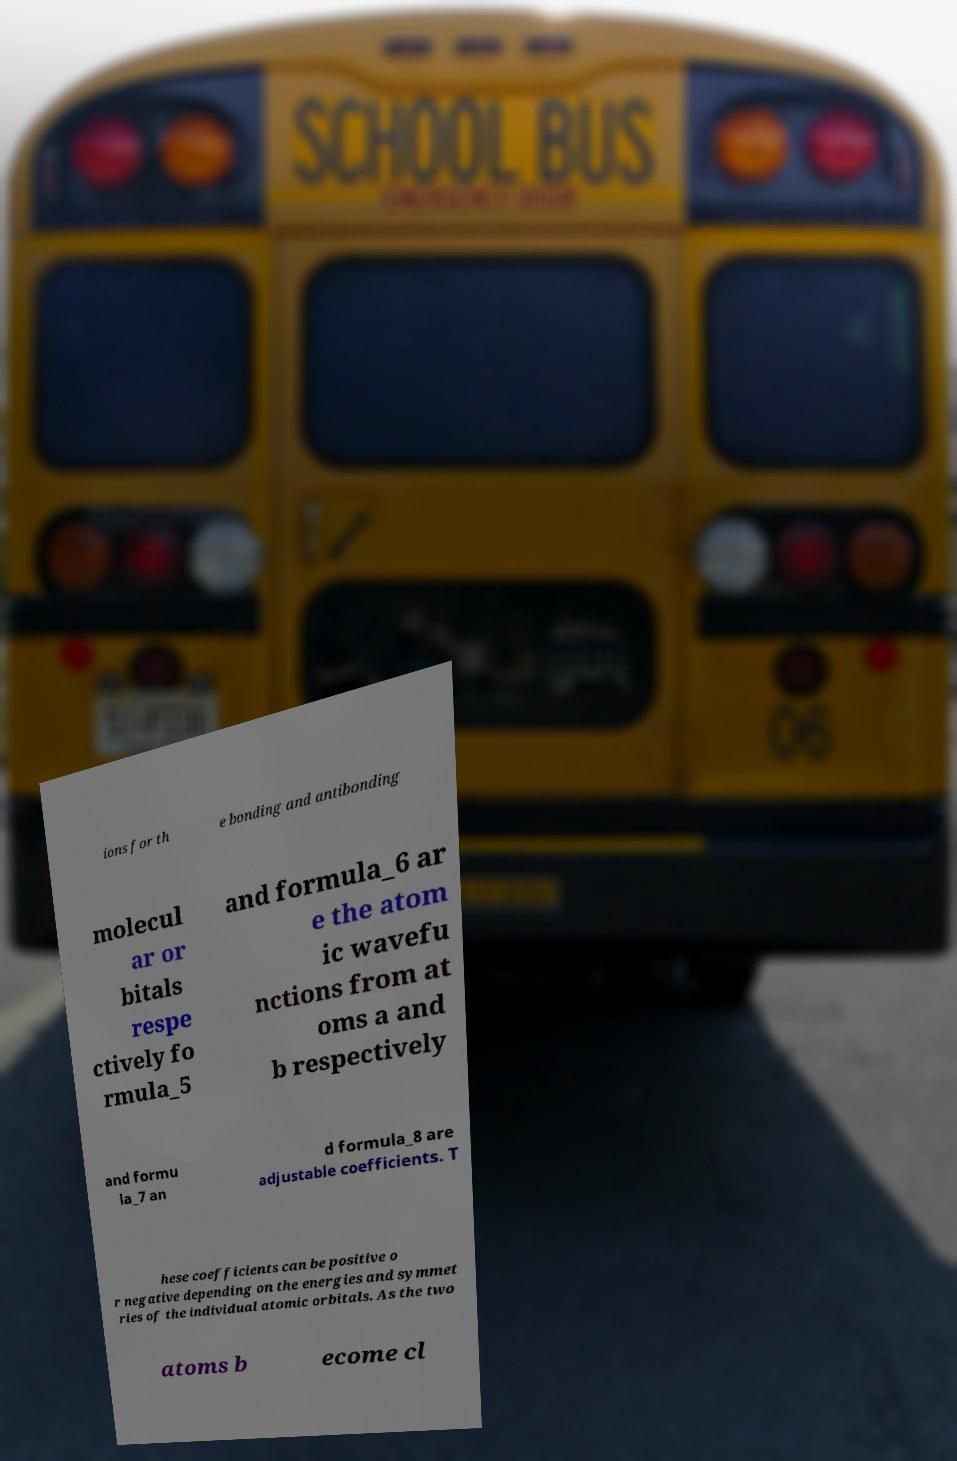There's text embedded in this image that I need extracted. Can you transcribe it verbatim? ions for th e bonding and antibonding molecul ar or bitals respe ctively fo rmula_5 and formula_6 ar e the atom ic wavefu nctions from at oms a and b respectively and formu la_7 an d formula_8 are adjustable coefficients. T hese coefficients can be positive o r negative depending on the energies and symmet ries of the individual atomic orbitals. As the two atoms b ecome cl 